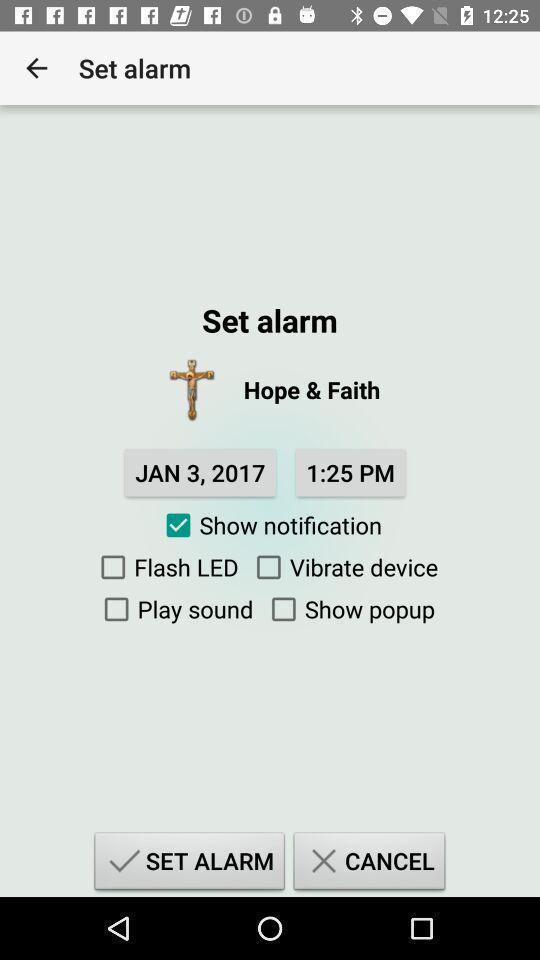Please provide a description for this image. Screen shows to set alarm. 